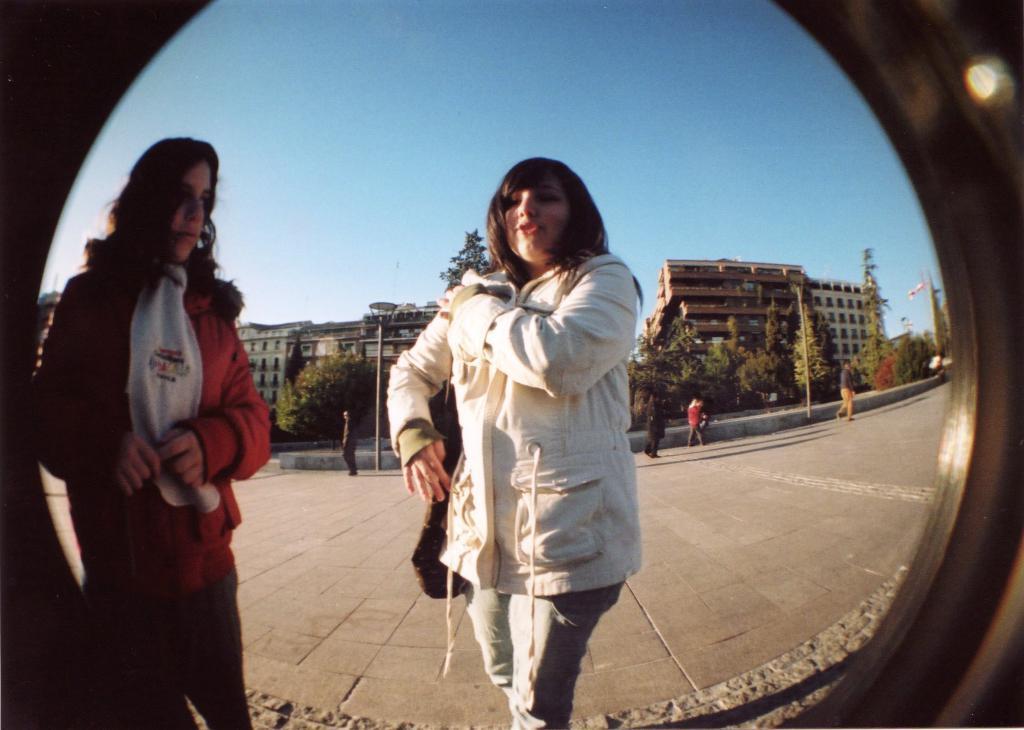Describe this image in one or two sentences. In this image I can see a circular glass through which I can see 2 women standing. There are other people, poles, trees and buildings at the back. 